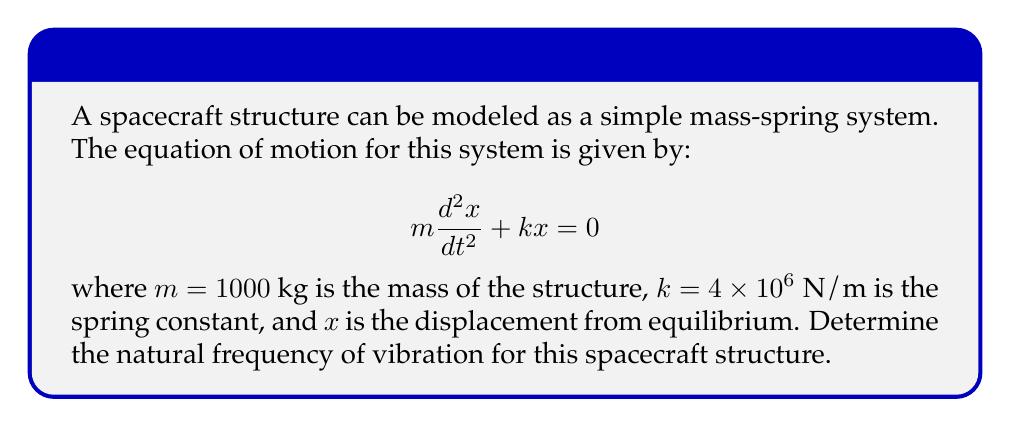Help me with this question. To solve this problem, we'll follow these steps:

1) The given equation is a second-order linear differential equation. For a system with natural frequency $\omega_n$, the general solution has the form:

   $$x(t) = A \cos(\omega_n t) + B \sin(\omega_n t)$$

2) Substituting this solution into the original equation:

   $$-m\omega_n^2[A \cos(\omega_n t) + B \sin(\omega_n t)] + k[A \cos(\omega_n t) + B \sin(\omega_n t)] = 0$$

3) For this to be true for all $t$, we must have:

   $$-m\omega_n^2 + k = 0$$

4) Solving for $\omega_n$:

   $$\omega_n^2 = \frac{k}{m}$$
   $$\omega_n = \sqrt{\frac{k}{m}}$$

5) Substituting the given values:

   $$\omega_n = \sqrt{\frac{4 \times 10^6}{1000}} = \sqrt{4000} = 20\sqrt{10} \approx 63.25 \text{ rad/s}$$

6) To convert from angular frequency (rad/s) to frequency (Hz), we divide by $2\pi$:

   $$f = \frac{\omega_n}{2\pi} = \frac{20\sqrt{10}}{2\pi} \approx 10.07 \text{ Hz}$$
Answer: The natural frequency of vibration for the spacecraft structure is approximately 10.07 Hz. 